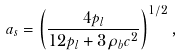Convert formula to latex. <formula><loc_0><loc_0><loc_500><loc_500>a _ { s } = \left ( \frac { 4 p _ { l } } { 1 2 p _ { l } + 3 \rho _ { b } c ^ { 2 } } \right ) ^ { 1 / 2 } ,</formula> 